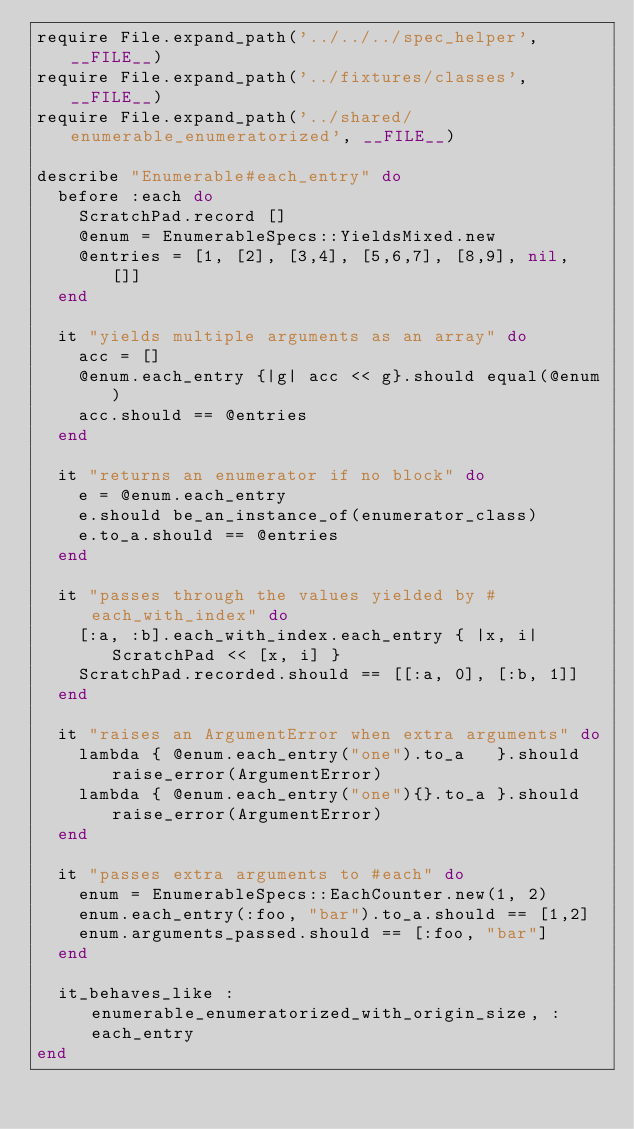<code> <loc_0><loc_0><loc_500><loc_500><_Ruby_>require File.expand_path('../../../spec_helper', __FILE__)
require File.expand_path('../fixtures/classes', __FILE__)
require File.expand_path('../shared/enumerable_enumeratorized', __FILE__)

describe "Enumerable#each_entry" do
  before :each do
    ScratchPad.record []
    @enum = EnumerableSpecs::YieldsMixed.new
    @entries = [1, [2], [3,4], [5,6,7], [8,9], nil, []]
  end

  it "yields multiple arguments as an array" do
    acc = []
    @enum.each_entry {|g| acc << g}.should equal(@enum)
    acc.should == @entries
  end

  it "returns an enumerator if no block" do
    e = @enum.each_entry
    e.should be_an_instance_of(enumerator_class)
    e.to_a.should == @entries
  end

  it "passes through the values yielded by #each_with_index" do
    [:a, :b].each_with_index.each_entry { |x, i| ScratchPad << [x, i] }
    ScratchPad.recorded.should == [[:a, 0], [:b, 1]]
  end

  it "raises an ArgumentError when extra arguments" do
    lambda { @enum.each_entry("one").to_a   }.should raise_error(ArgumentError)
    lambda { @enum.each_entry("one"){}.to_a }.should raise_error(ArgumentError)
  end

  it "passes extra arguments to #each" do
    enum = EnumerableSpecs::EachCounter.new(1, 2)
    enum.each_entry(:foo, "bar").to_a.should == [1,2]
    enum.arguments_passed.should == [:foo, "bar"]
  end

  it_behaves_like :enumerable_enumeratorized_with_origin_size, :each_entry
end
</code> 